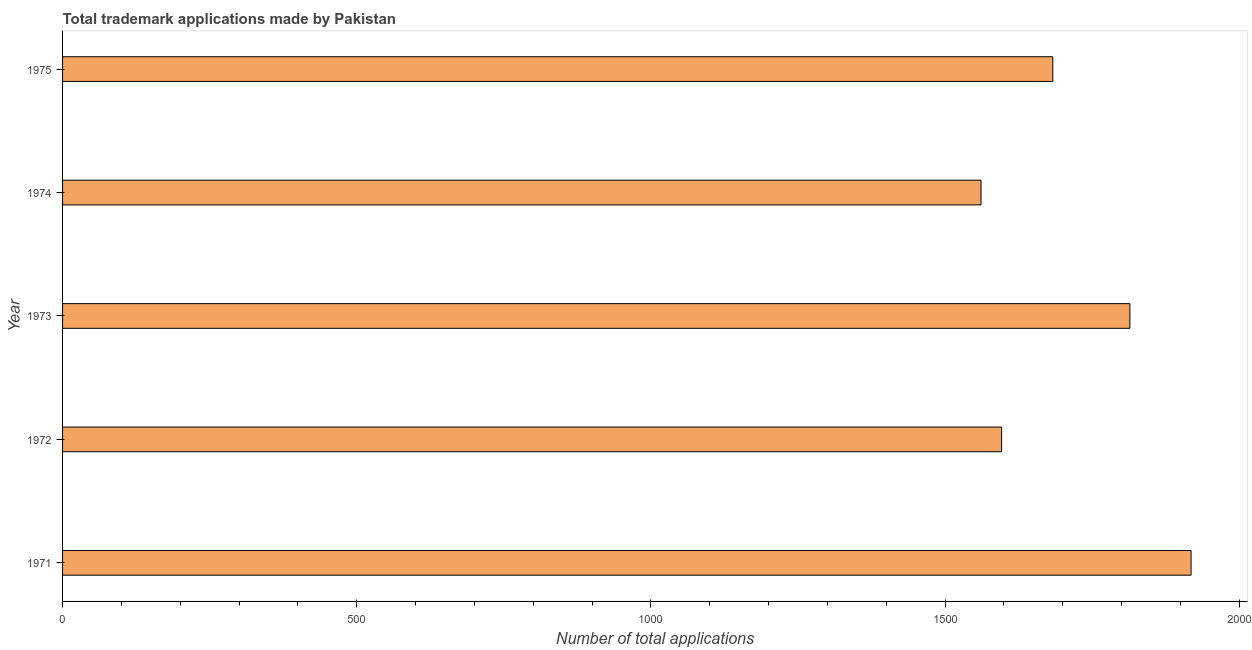Does the graph contain any zero values?
Give a very brief answer. No. What is the title of the graph?
Ensure brevity in your answer.  Total trademark applications made by Pakistan. What is the label or title of the X-axis?
Make the answer very short. Number of total applications. What is the number of trademark applications in 1975?
Offer a very short reply. 1683. Across all years, what is the maximum number of trademark applications?
Your response must be concise. 1918. Across all years, what is the minimum number of trademark applications?
Make the answer very short. 1561. In which year was the number of trademark applications minimum?
Ensure brevity in your answer.  1974. What is the sum of the number of trademark applications?
Your answer should be compact. 8572. What is the difference between the number of trademark applications in 1972 and 1973?
Give a very brief answer. -218. What is the average number of trademark applications per year?
Provide a short and direct response. 1714. What is the median number of trademark applications?
Your response must be concise. 1683. In how many years, is the number of trademark applications greater than 1100 ?
Your answer should be very brief. 5. What is the ratio of the number of trademark applications in 1971 to that in 1974?
Offer a terse response. 1.23. Is the difference between the number of trademark applications in 1971 and 1974 greater than the difference between any two years?
Keep it short and to the point. Yes. What is the difference between the highest and the second highest number of trademark applications?
Provide a succinct answer. 104. Is the sum of the number of trademark applications in 1971 and 1974 greater than the maximum number of trademark applications across all years?
Your answer should be very brief. Yes. What is the difference between the highest and the lowest number of trademark applications?
Make the answer very short. 357. In how many years, is the number of trademark applications greater than the average number of trademark applications taken over all years?
Offer a terse response. 2. Are all the bars in the graph horizontal?
Your answer should be very brief. Yes. What is the difference between two consecutive major ticks on the X-axis?
Offer a very short reply. 500. Are the values on the major ticks of X-axis written in scientific E-notation?
Ensure brevity in your answer.  No. What is the Number of total applications of 1971?
Keep it short and to the point. 1918. What is the Number of total applications of 1972?
Your response must be concise. 1596. What is the Number of total applications in 1973?
Make the answer very short. 1814. What is the Number of total applications of 1974?
Make the answer very short. 1561. What is the Number of total applications of 1975?
Offer a very short reply. 1683. What is the difference between the Number of total applications in 1971 and 1972?
Provide a succinct answer. 322. What is the difference between the Number of total applications in 1971 and 1973?
Your answer should be very brief. 104. What is the difference between the Number of total applications in 1971 and 1974?
Keep it short and to the point. 357. What is the difference between the Number of total applications in 1971 and 1975?
Ensure brevity in your answer.  235. What is the difference between the Number of total applications in 1972 and 1973?
Offer a very short reply. -218. What is the difference between the Number of total applications in 1972 and 1974?
Provide a short and direct response. 35. What is the difference between the Number of total applications in 1972 and 1975?
Provide a succinct answer. -87. What is the difference between the Number of total applications in 1973 and 1974?
Give a very brief answer. 253. What is the difference between the Number of total applications in 1973 and 1975?
Make the answer very short. 131. What is the difference between the Number of total applications in 1974 and 1975?
Ensure brevity in your answer.  -122. What is the ratio of the Number of total applications in 1971 to that in 1972?
Keep it short and to the point. 1.2. What is the ratio of the Number of total applications in 1971 to that in 1973?
Your answer should be very brief. 1.06. What is the ratio of the Number of total applications in 1971 to that in 1974?
Keep it short and to the point. 1.23. What is the ratio of the Number of total applications in 1971 to that in 1975?
Provide a succinct answer. 1.14. What is the ratio of the Number of total applications in 1972 to that in 1975?
Your answer should be compact. 0.95. What is the ratio of the Number of total applications in 1973 to that in 1974?
Offer a very short reply. 1.16. What is the ratio of the Number of total applications in 1973 to that in 1975?
Offer a very short reply. 1.08. What is the ratio of the Number of total applications in 1974 to that in 1975?
Make the answer very short. 0.93. 